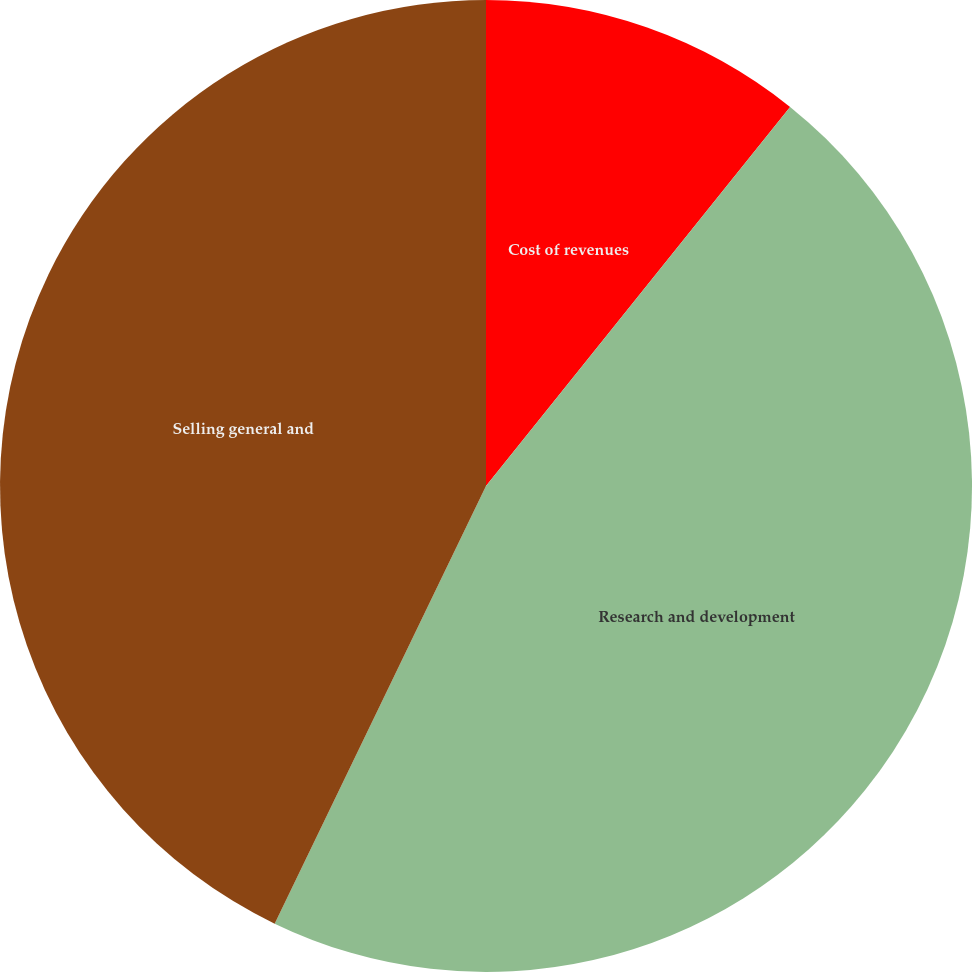Convert chart to OTSL. <chart><loc_0><loc_0><loc_500><loc_500><pie_chart><fcel>Cost of revenues<fcel>Research and development<fcel>Selling general and<nl><fcel>10.76%<fcel>46.4%<fcel>42.84%<nl></chart> 